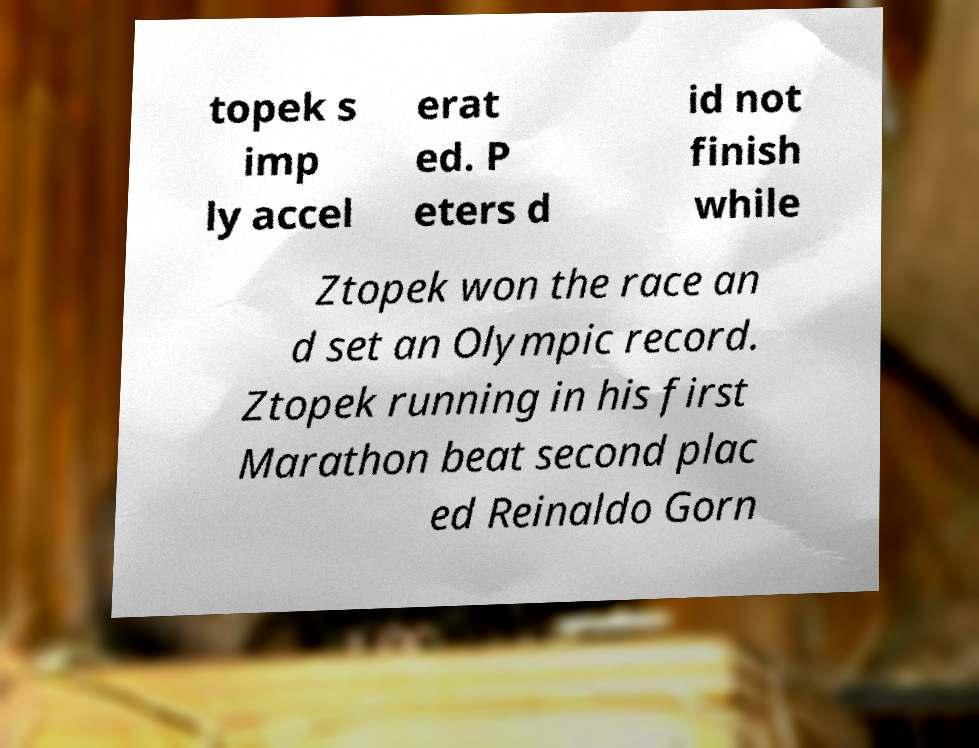Could you extract and type out the text from this image? topek s imp ly accel erat ed. P eters d id not finish while Ztopek won the race an d set an Olympic record. Ztopek running in his first Marathon beat second plac ed Reinaldo Gorn 